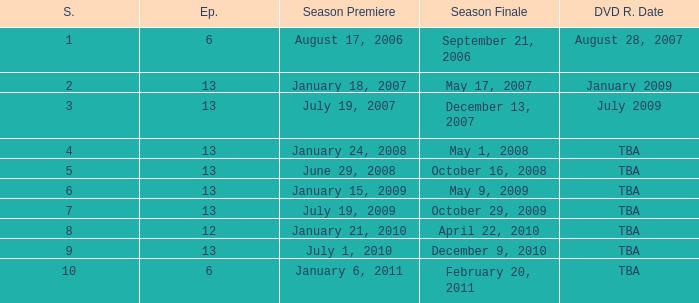On what date was the DVD released for the season with fewer than 13 episodes that aired before season 8? August 28, 2007. 